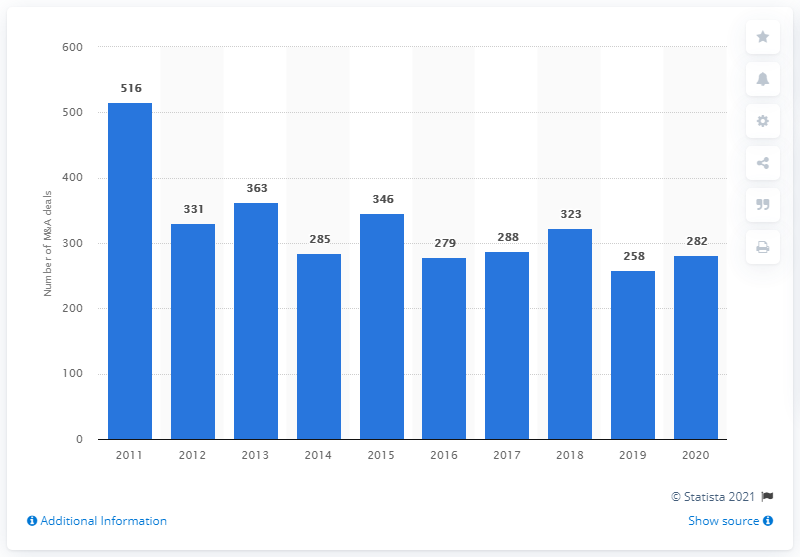Outline some significant characteristics in this image. There were 282 completed mergers and acquisitions in 2019. In the previous year, a total of 258 M&A deals were completed. 